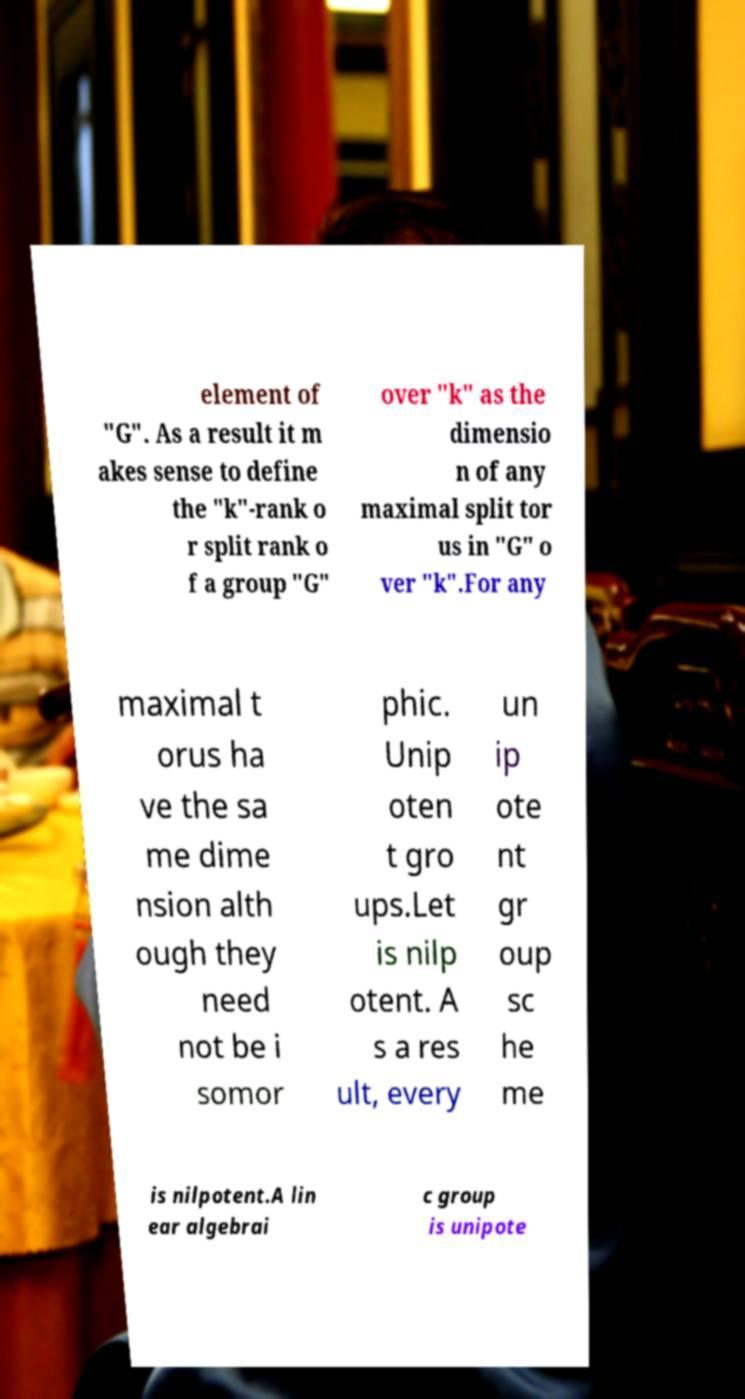Could you assist in decoding the text presented in this image and type it out clearly? element of "G". As a result it m akes sense to define the "k"-rank o r split rank o f a group "G" over "k" as the dimensio n of any maximal split tor us in "G" o ver "k".For any maximal t orus ha ve the sa me dime nsion alth ough they need not be i somor phic. Unip oten t gro ups.Let is nilp otent. A s a res ult, every un ip ote nt gr oup sc he me is nilpotent.A lin ear algebrai c group is unipote 